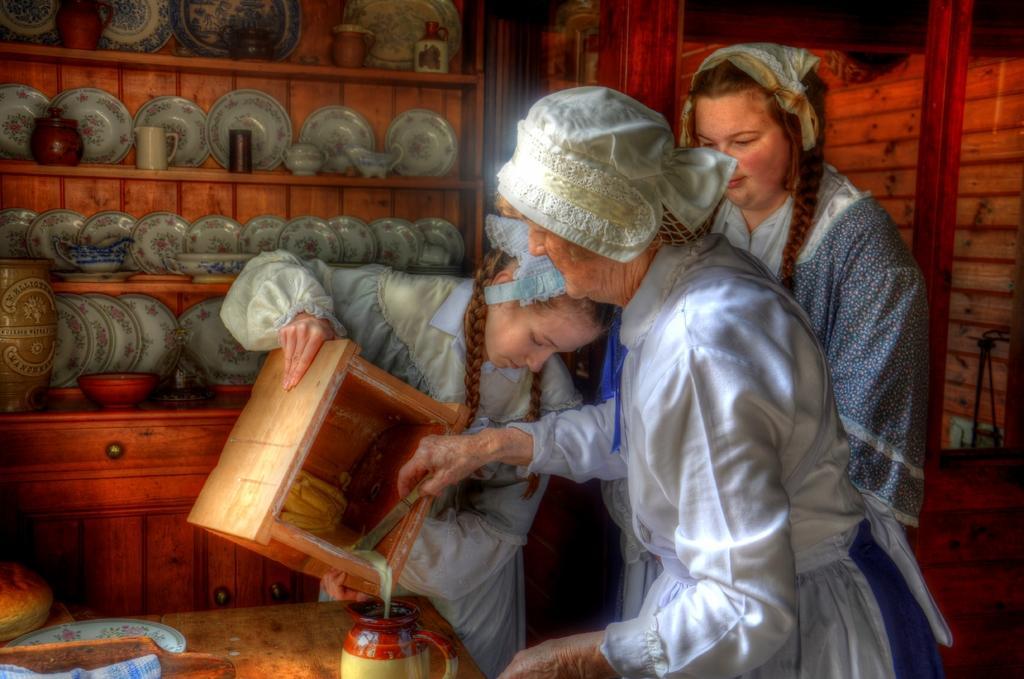How would you summarize this image in a sentence or two? In this picture there are three women were wearing the white dress. The girl is holding a wooden box and the old woman is holding a knife. On the table we can see the plate, basket and cloth. In the back we can see the plates, cups and other objects on the wooden rack. On the right there is a door. 